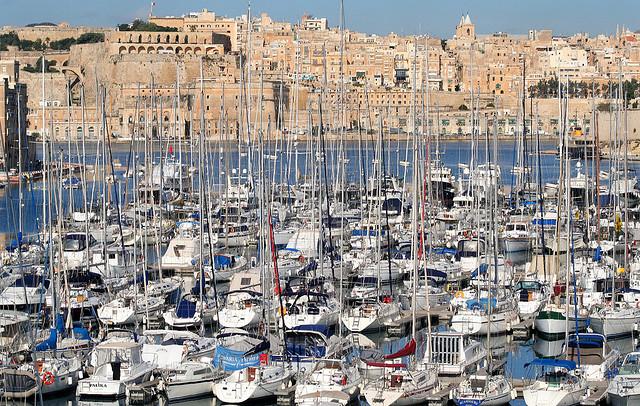How many boats are in the harbor?
Concise answer only. Lot. What is the most common boat color here?
Quick response, please. White. Does this appear to be a European port?
Be succinct. Yes. 